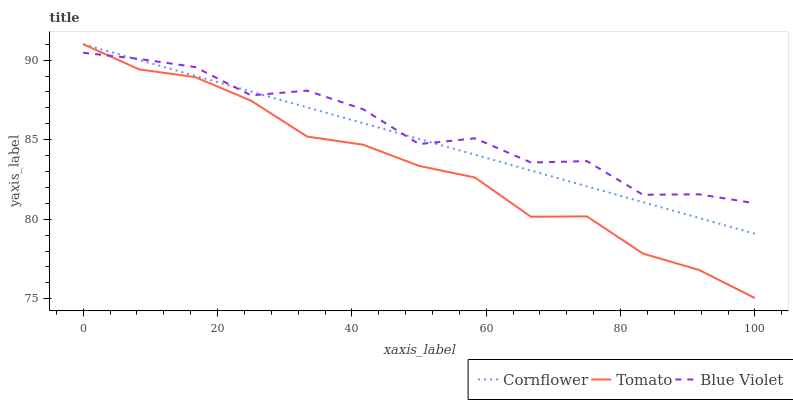Does Cornflower have the minimum area under the curve?
Answer yes or no. No. Does Cornflower have the maximum area under the curve?
Answer yes or no. No. Is Blue Violet the smoothest?
Answer yes or no. No. Is Cornflower the roughest?
Answer yes or no. No. Does Cornflower have the lowest value?
Answer yes or no. No. Does Blue Violet have the highest value?
Answer yes or no. No. 